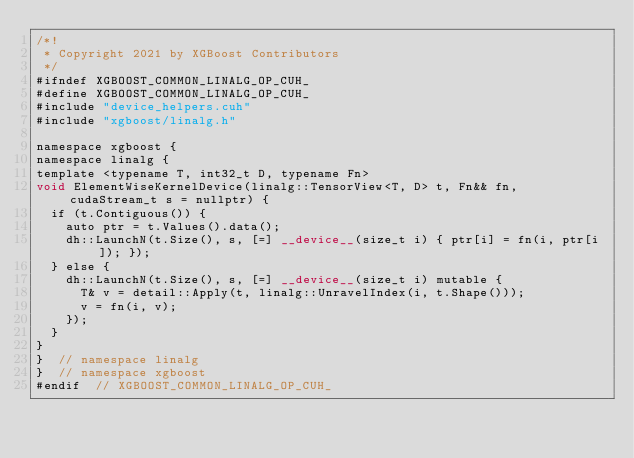<code> <loc_0><loc_0><loc_500><loc_500><_Cuda_>/*!
 * Copyright 2021 by XGBoost Contributors
 */
#ifndef XGBOOST_COMMON_LINALG_OP_CUH_
#define XGBOOST_COMMON_LINALG_OP_CUH_
#include "device_helpers.cuh"
#include "xgboost/linalg.h"

namespace xgboost {
namespace linalg {
template <typename T, int32_t D, typename Fn>
void ElementWiseKernelDevice(linalg::TensorView<T, D> t, Fn&& fn, cudaStream_t s = nullptr) {
  if (t.Contiguous()) {
    auto ptr = t.Values().data();
    dh::LaunchN(t.Size(), s, [=] __device__(size_t i) { ptr[i] = fn(i, ptr[i]); });
  } else {
    dh::LaunchN(t.Size(), s, [=] __device__(size_t i) mutable {
      T& v = detail::Apply(t, linalg::UnravelIndex(i, t.Shape()));
      v = fn(i, v);
    });
  }
}
}  // namespace linalg
}  // namespace xgboost
#endif  // XGBOOST_COMMON_LINALG_OP_CUH_
</code> 